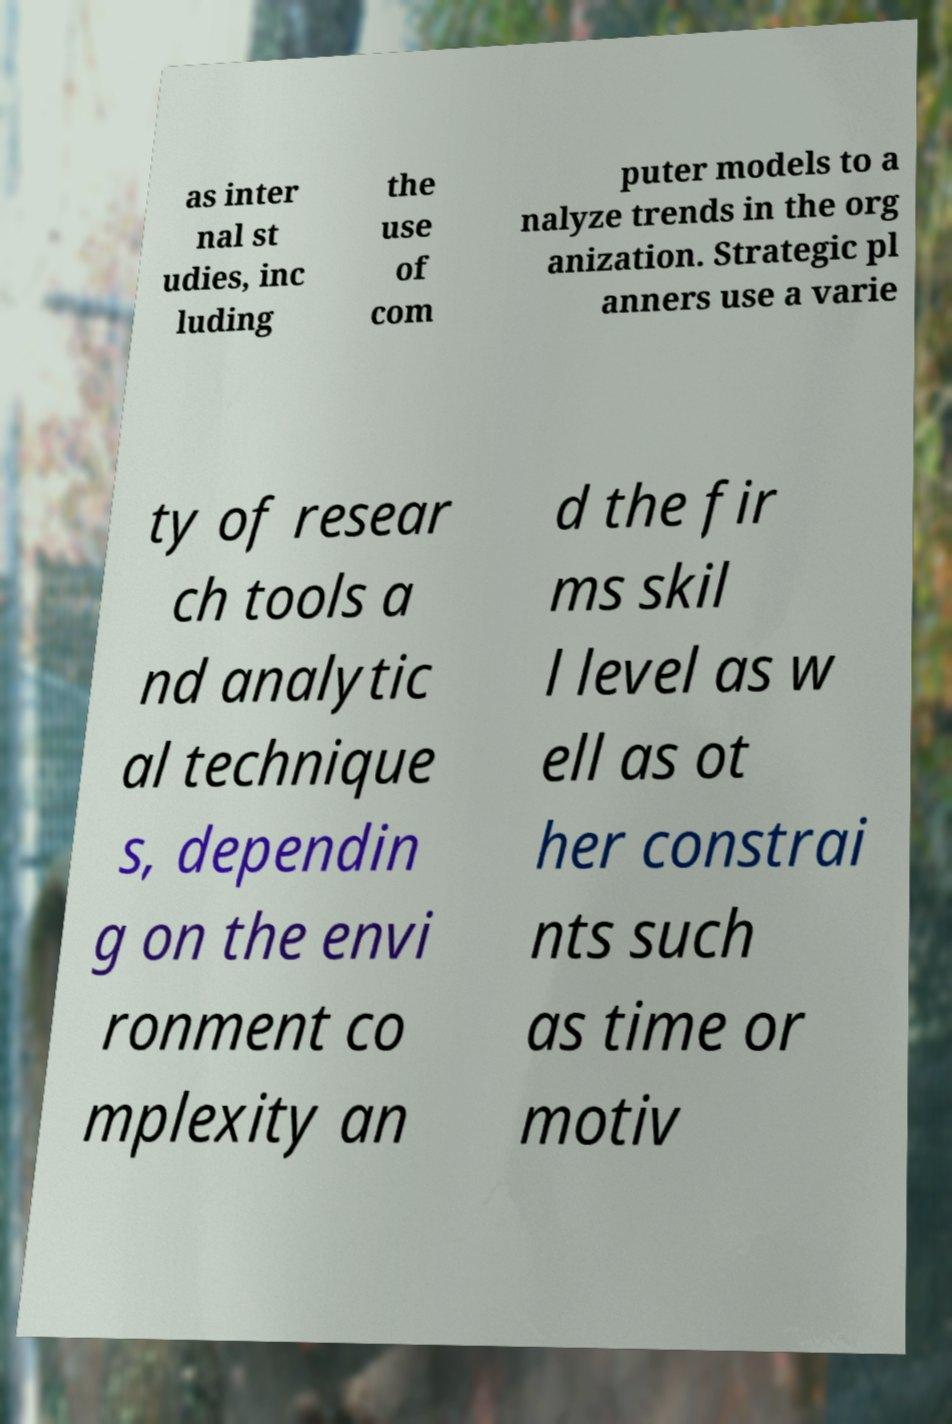There's text embedded in this image that I need extracted. Can you transcribe it verbatim? as inter nal st udies, inc luding the use of com puter models to a nalyze trends in the org anization. Strategic pl anners use a varie ty of resear ch tools a nd analytic al technique s, dependin g on the envi ronment co mplexity an d the fir ms skil l level as w ell as ot her constrai nts such as time or motiv 